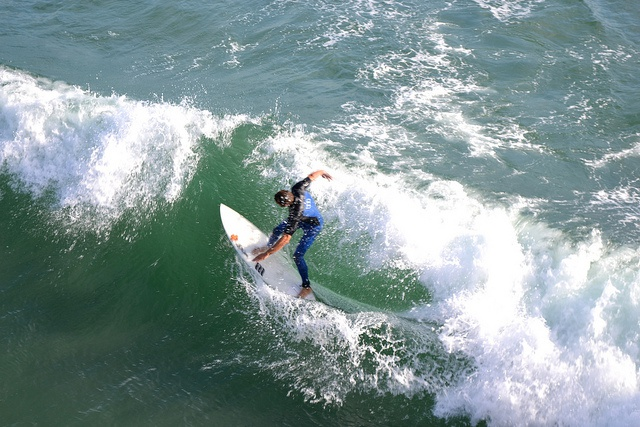Describe the objects in this image and their specific colors. I can see people in gray, black, navy, and darkgray tones and surfboard in gray, white, and darkgray tones in this image. 